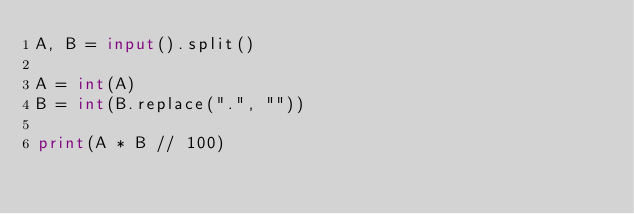Convert code to text. <code><loc_0><loc_0><loc_500><loc_500><_Python_>A, B = input().split()

A = int(A)
B = int(B.replace(".", ""))

print(A * B // 100)
</code> 